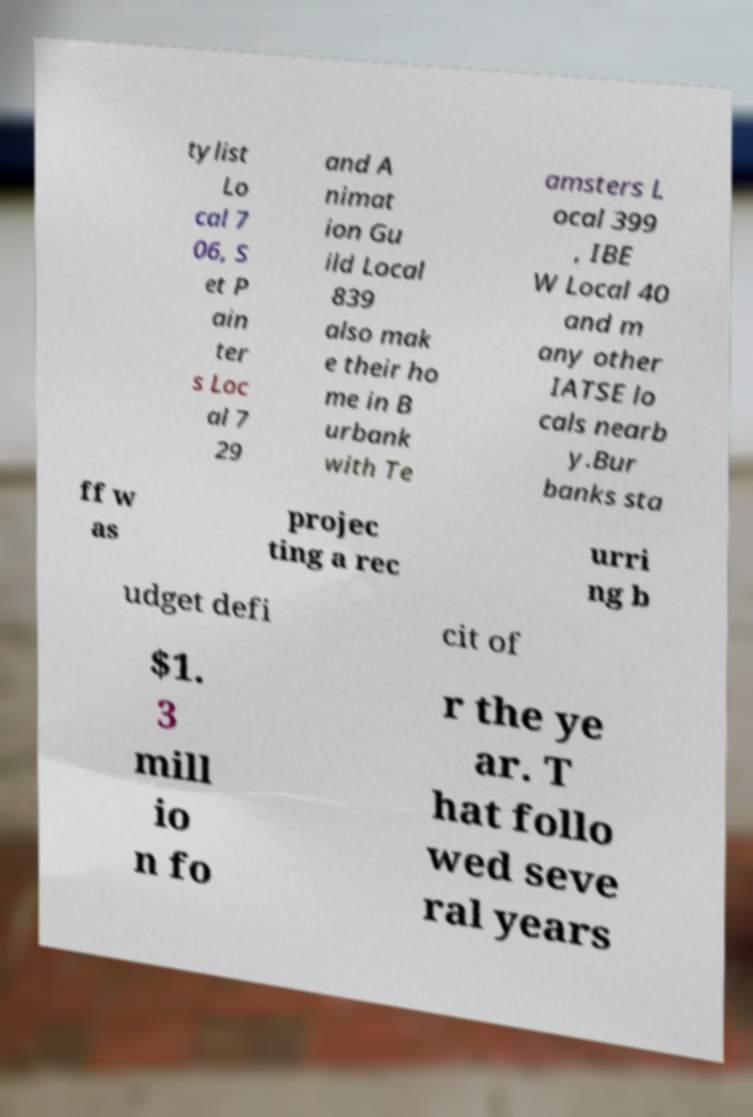Could you assist in decoding the text presented in this image and type it out clearly? tylist Lo cal 7 06, S et P ain ter s Loc al 7 29 and A nimat ion Gu ild Local 839 also mak e their ho me in B urbank with Te amsters L ocal 399 , IBE W Local 40 and m any other IATSE lo cals nearb y.Bur banks sta ff w as projec ting a rec urri ng b udget defi cit of $1. 3 mill io n fo r the ye ar. T hat follo wed seve ral years 